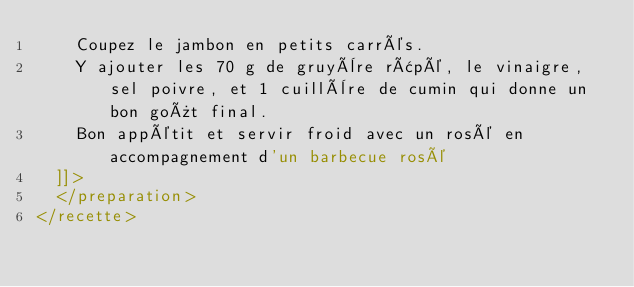Convert code to text. <code><loc_0><loc_0><loc_500><loc_500><_XML_>    Coupez le jambon en petits carrés. 
    Y ajouter les 70 g de gruyère râpé, le vinaigre, sel poivre, et 1 cuillère de cumin qui donne un bon goût final. 
    Bon appétit et servir froid avec un rosé en accompagnement d'un barbecue rosé
  ]]>
  </preparation>
</recette>
</code> 